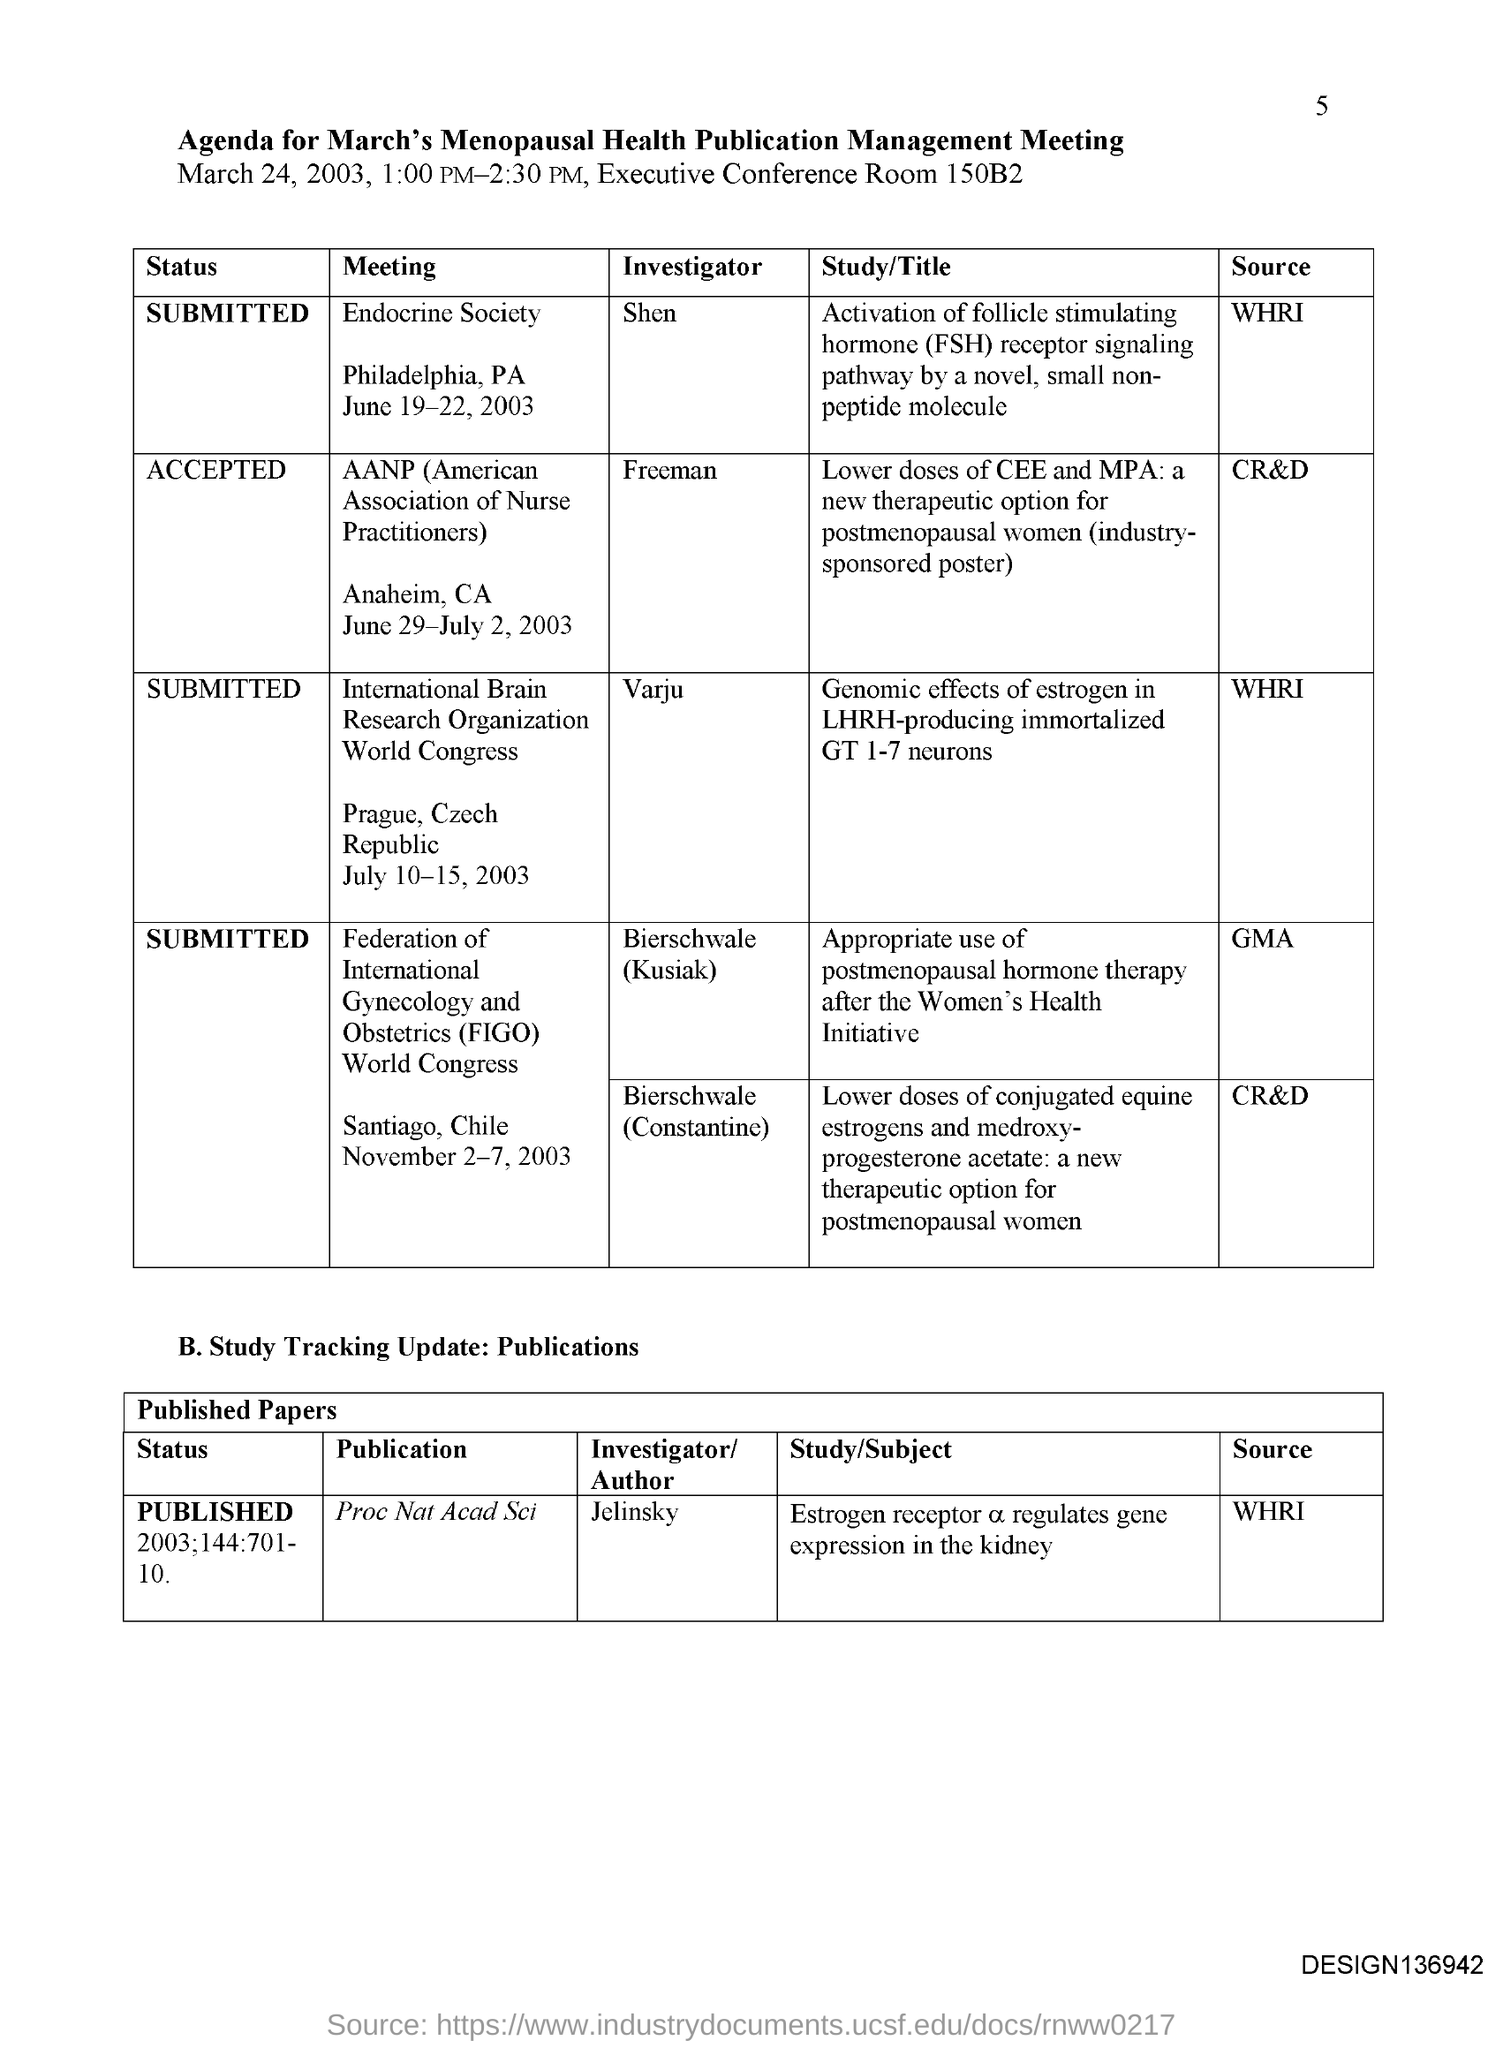Identify some key points in this picture. The Proceedings of the National Academy of Sciences (PNAS) is a publication source that is provided by the WHRI (Western Humanities Resources Initiative). The source for the Endocrine Society meeting is the World Health Research Institute (WHRI). The Endocrine Society meeting is held in Philadelphia, Pennsylvania. The American Association of Nurse Practitioners (AANP) conference is held annually in Anaheim, California. The investigator for the AANP meeting is Freeman. 